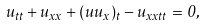Convert formula to latex. <formula><loc_0><loc_0><loc_500><loc_500>u _ { t t } + u _ { x x } + ( u u _ { x } ) _ { t } - u _ { x x t t } = 0 ,</formula> 